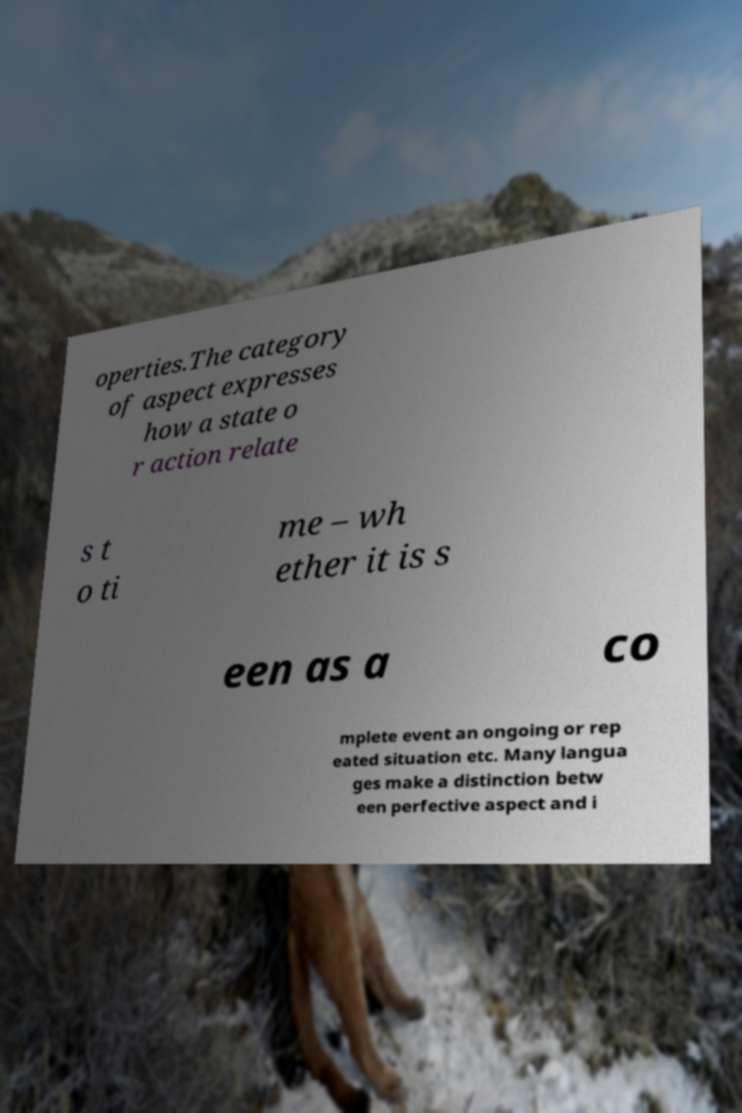Can you accurately transcribe the text from the provided image for me? operties.The category of aspect expresses how a state o r action relate s t o ti me – wh ether it is s een as a co mplete event an ongoing or rep eated situation etc. Many langua ges make a distinction betw een perfective aspect and i 